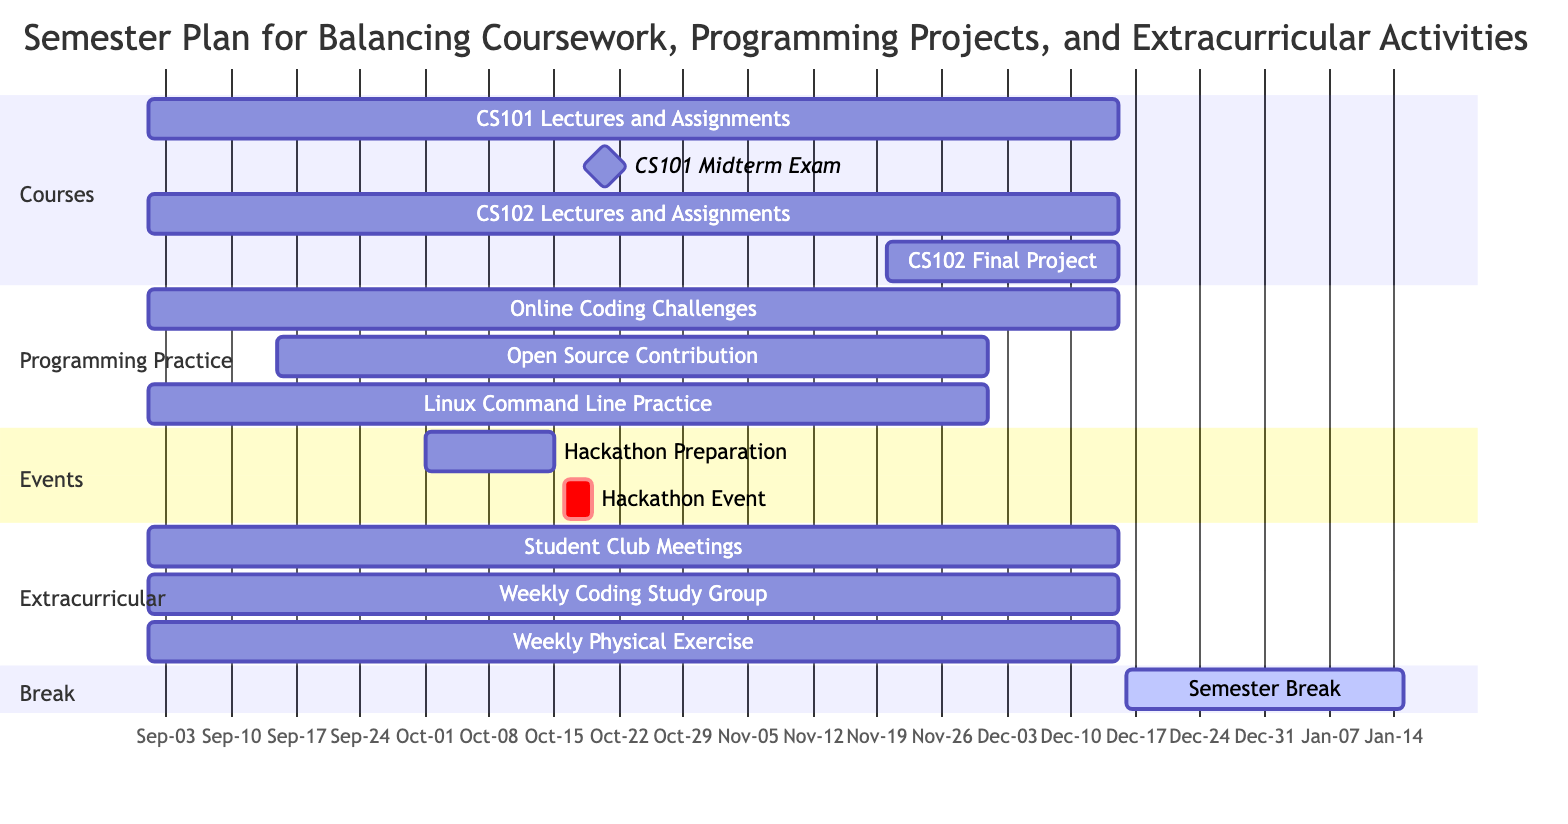What is the duration of the CS101 Lectures and Assignments? The start date is September 1, 2023, and the end date is December 15, 2023. Therefore, the duration is calculated from the start to the end dates. The difference gives a duration of approximately 3 months and 15 days, so the answer focuses on the overall time span.
Answer: 3 months and 15 days When is the CS102 Final Project scheduled to start? Referring to the section of the diagram for courses, the CS102 Final Project has a start date of November 20, 2023, listed directly next to this task in the timeline.
Answer: November 20, 2023 How many subtasks are associated with the Linux Command Line Practice Sessions? Checking the "subtasks" related to Linux Command Line Practice in the provided data, there are three subtasks: Learn Basic Commands, Shell Scripting, and Advanced Usage. Counting these provides the total number of subtasks.
Answer: 3 Which task overlaps with the Hackathon Event? The Hackathon Event occurs from October 16 to October 18, 2023. In the diagram, the Hackathon Preparation task runs from October 1 to October 15, so the Hackathon Event overlaps with this preparation task. By evaluating both activities' timelines, we see they share time.
Answer: Hackathon Preparation What is the end date of the Semester Break? The Semester Break has an explicit end date of January 15, 2024, which is specified in the diagram for this particular section and helps indicate a distinct break period between semesters.
Answer: January 15, 2024 How long do the Weekly Coding Study Group meetings last? The Weekly Coding Study Group started on September 1, 2023, and will continue until December 15, 2023. By examining the section on Extracurricular activities, we determine their total duration spans the same period as CS101 and CS102 coursework.
Answer: 3 months and 15 days What is the start date of Open Source Contribution? According to the data, Open Source Contribution begins on September 15, 2023, which is outlined in the Programming Practice section of the chart. This specific date is indicated clearly in the timeline.
Answer: September 15, 2023 Which two tasks related to Extracurricular activities overlap the most in their scheduling? By inspecting the weekly schedules for Extracurricular activities, both Weekly Physical Exercise and Student Club Meetings began on September 1, 2023, and continue until December 15, 2023. Both have identical timelines, resulting in full overlap of their scheduling.
Answer: Student Club Meetings, Weekly Physical Exercise 